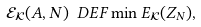<formula> <loc_0><loc_0><loc_500><loc_500>\mathcal { E } _ { \mathcal { K } } ( A , N ) \ D E F \min E _ { \mathcal { K } } ( Z _ { N } ) ,</formula> 